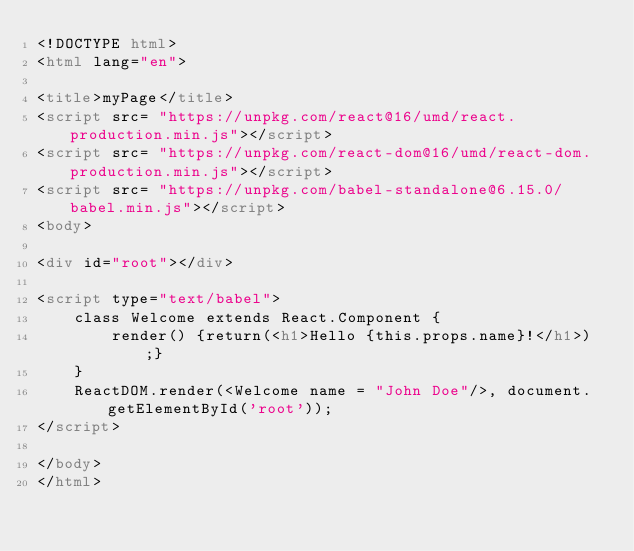Convert code to text. <code><loc_0><loc_0><loc_500><loc_500><_HTML_><!DOCTYPE html>
<html lang="en">

<title>myPage</title>
<script src= "https://unpkg.com/react@16/umd/react.production.min.js"></script>
<script src= "https://unpkg.com/react-dom@16/umd/react-dom.production.min.js"></script>
<script src= "https://unpkg.com/babel-standalone@6.15.0/babel.min.js"></script>
<body>

<div id="root"></div>

<script type="text/babel">
    class Welcome extends React.Component {
        render() {return(<h1>Hello {this.props.name}!</h1>);}
    }
    ReactDOM.render(<Welcome name = "John Doe"/>, document.getElementById('root'));
</script>

</body>
</html>
</code> 